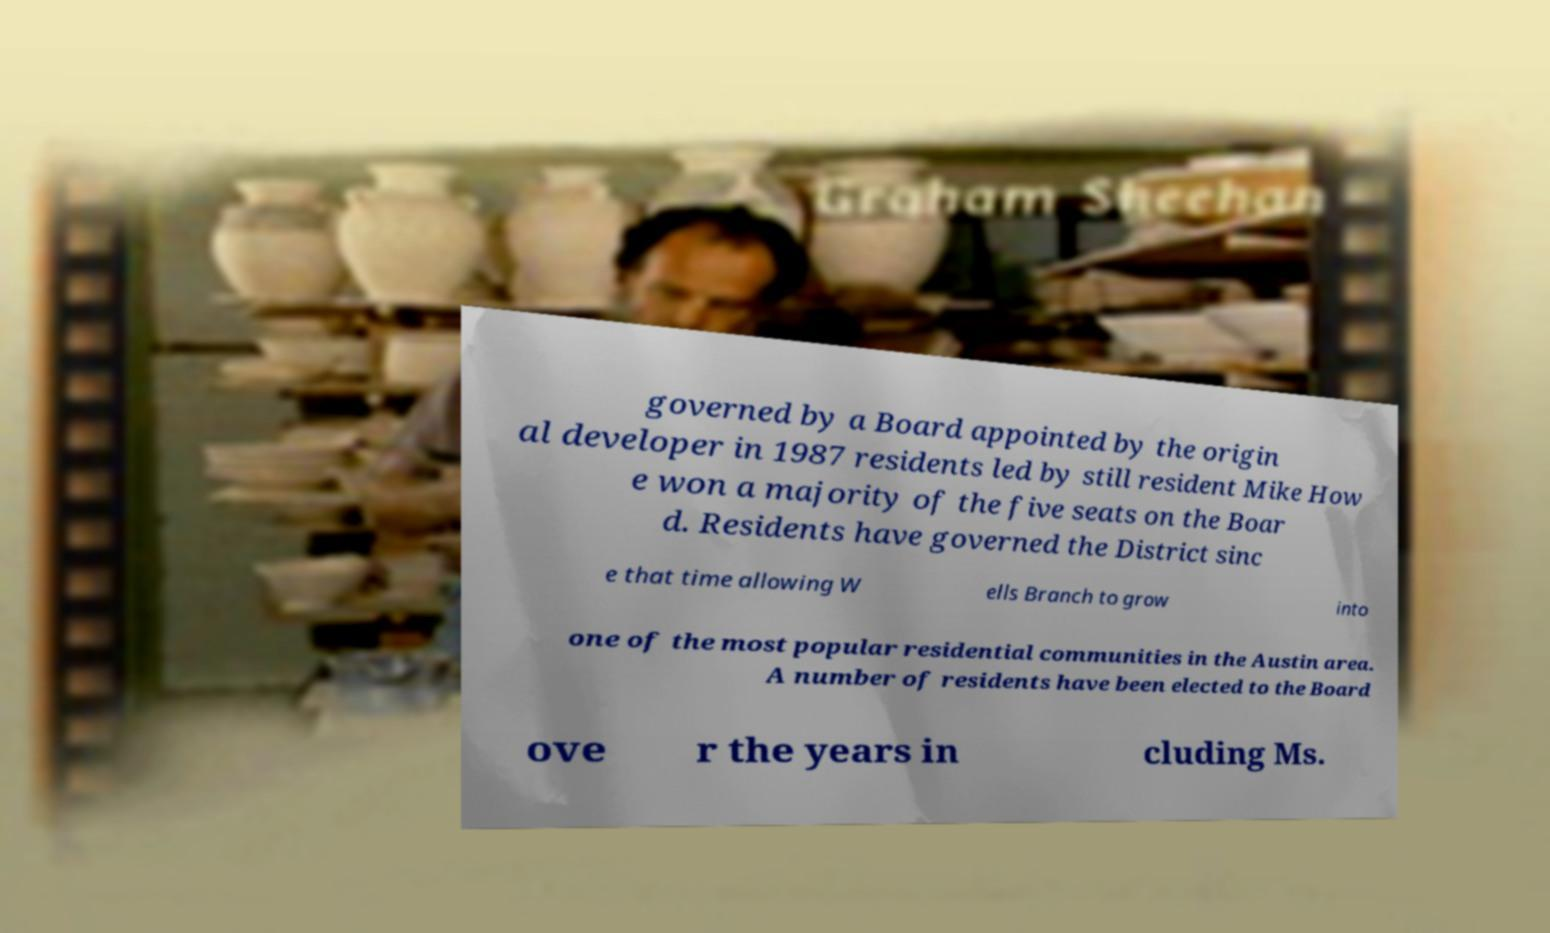There's text embedded in this image that I need extracted. Can you transcribe it verbatim? governed by a Board appointed by the origin al developer in 1987 residents led by still resident Mike How e won a majority of the five seats on the Boar d. Residents have governed the District sinc e that time allowing W ells Branch to grow into one of the most popular residential communities in the Austin area. A number of residents have been elected to the Board ove r the years in cluding Ms. 